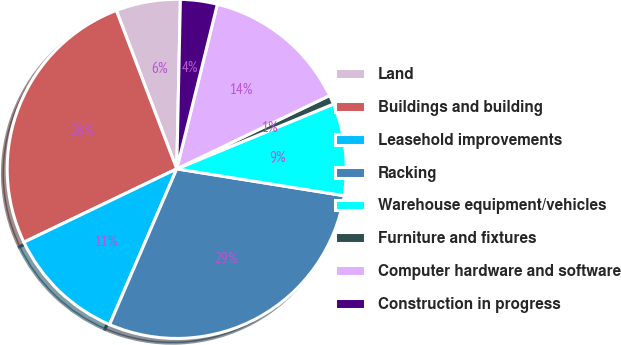<chart> <loc_0><loc_0><loc_500><loc_500><pie_chart><fcel>Land<fcel>Buildings and building<fcel>Leasehold improvements<fcel>Racking<fcel>Warehouse equipment/vehicles<fcel>Furniture and fixtures<fcel>Computer hardware and software<fcel>Construction in progress<nl><fcel>6.14%<fcel>26.32%<fcel>11.4%<fcel>28.95%<fcel>8.77%<fcel>0.88%<fcel>14.03%<fcel>3.51%<nl></chart> 